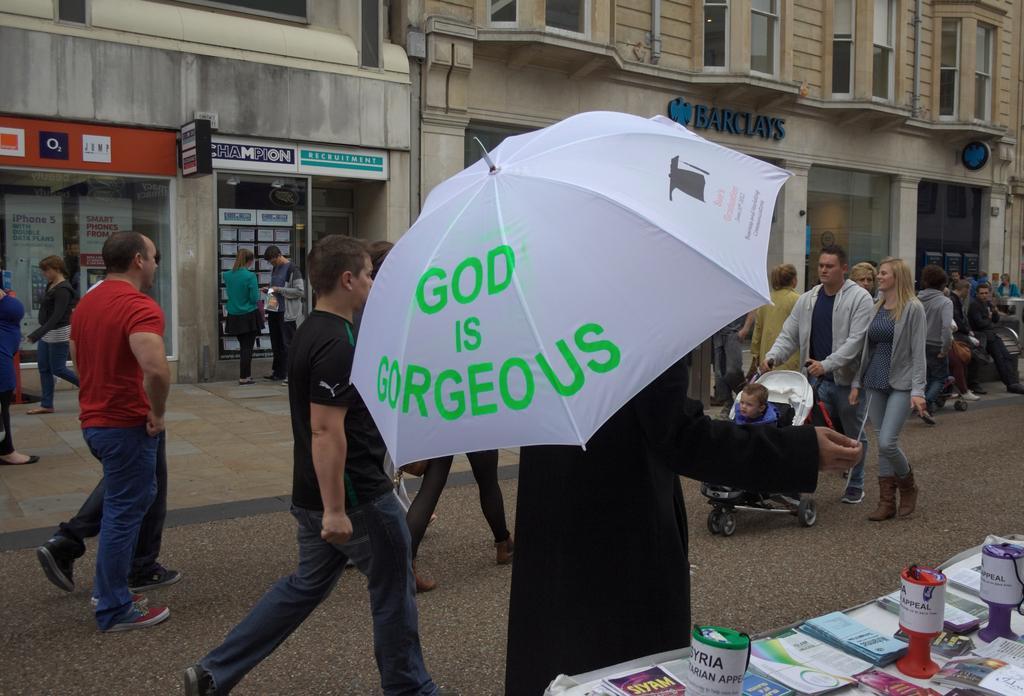Could you give a brief overview of what you see in this image? In this image, we can see a person holding an umbrella. There are some persons wearing clothes and walking on the road beside the building. There is a table in the bottom right of the image contains some books and cups. 